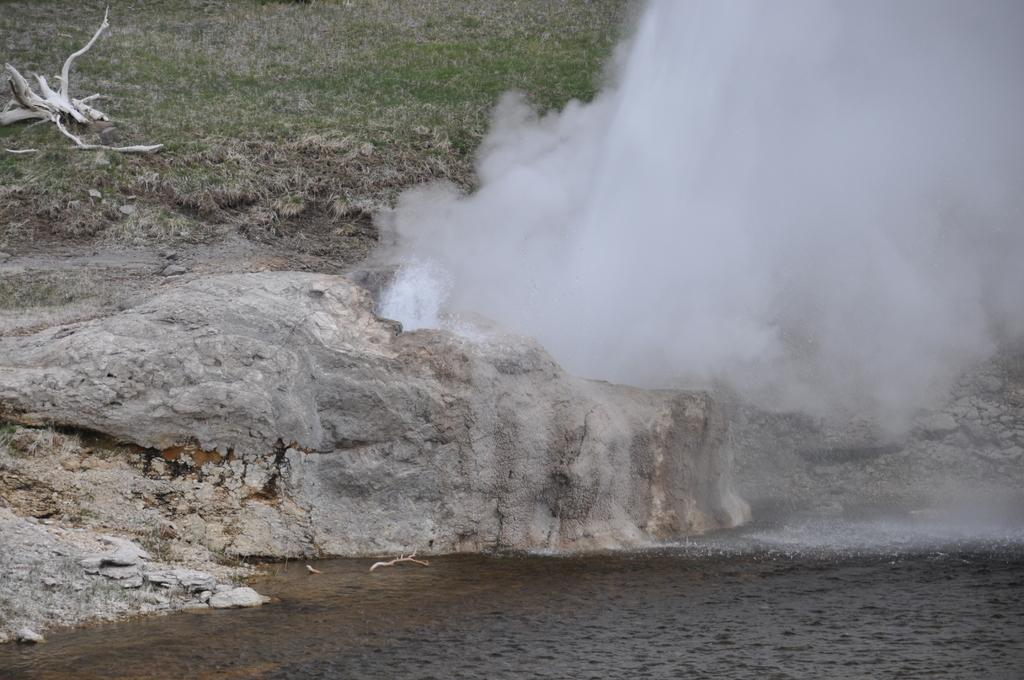Please provide a concise description of this image. In this image we can see grassy land, waterfall, rocky surface, wood and water body. 